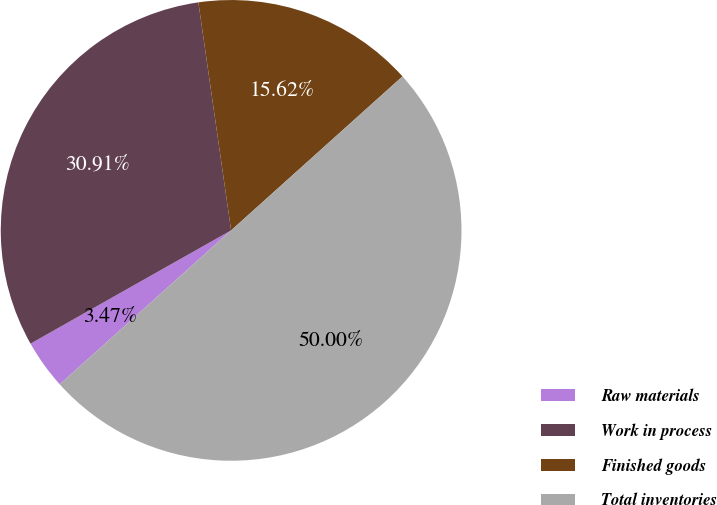<chart> <loc_0><loc_0><loc_500><loc_500><pie_chart><fcel>Raw materials<fcel>Work in process<fcel>Finished goods<fcel>Total inventories<nl><fcel>3.47%<fcel>30.91%<fcel>15.62%<fcel>50.0%<nl></chart> 